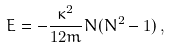Convert formula to latex. <formula><loc_0><loc_0><loc_500><loc_500>E = - \frac { \kappa ^ { 2 } } { 1 2 m } N ( N ^ { 2 } - 1 ) \, ,</formula> 